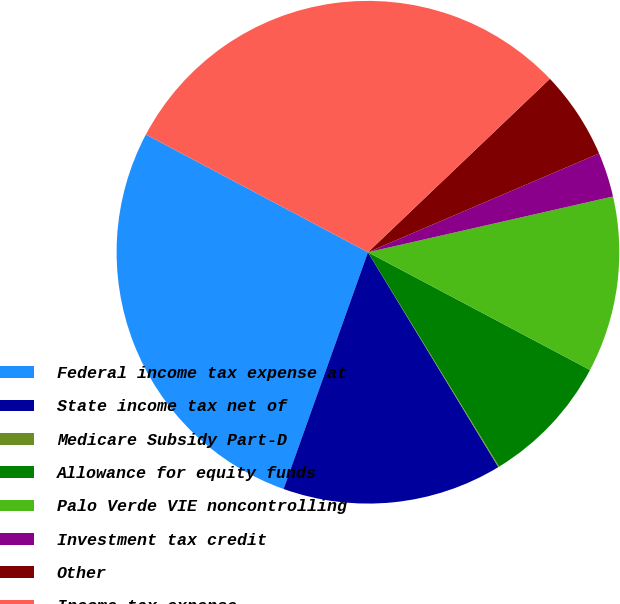<chart> <loc_0><loc_0><loc_500><loc_500><pie_chart><fcel>Federal income tax expense at<fcel>State income tax net of<fcel>Medicare Subsidy Part-D<fcel>Allowance for equity funds<fcel>Palo Verde VIE noncontrolling<fcel>Investment tax credit<fcel>Other<fcel>Income tax expense -<nl><fcel>27.31%<fcel>14.13%<fcel>0.06%<fcel>8.5%<fcel>11.32%<fcel>2.87%<fcel>5.69%<fcel>30.12%<nl></chart> 